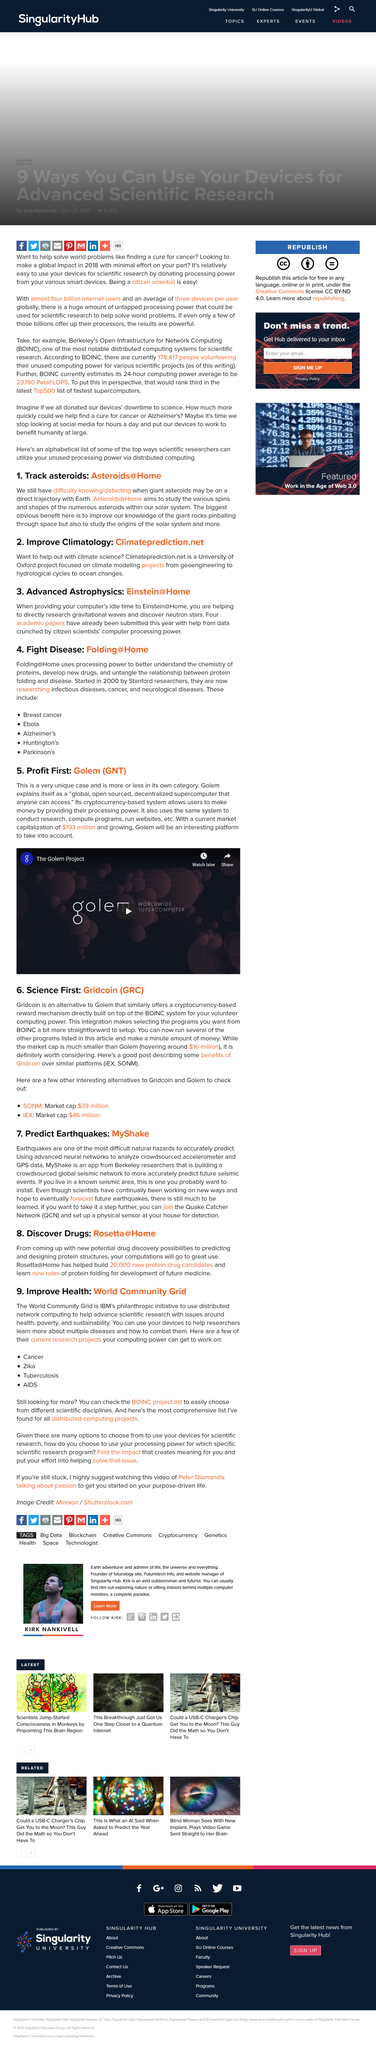Point out several critical features in this image. Rosetta@Home has helped build approximately 20,000 new protein drug candidates. The concept of Golem is fundamentally that of a supercomputer, offering unparalleled processing power and capabilities for a wide range of applications. The Quake Catcher Network is abbreviated by three letters, QCN. The current market capitalization of Golem is $193 million as of [date]. IBM initiated the World Community Grid, a company that provides computing power to researchers and scientists working on a variety of projects related to health, poverty, and the environment. 